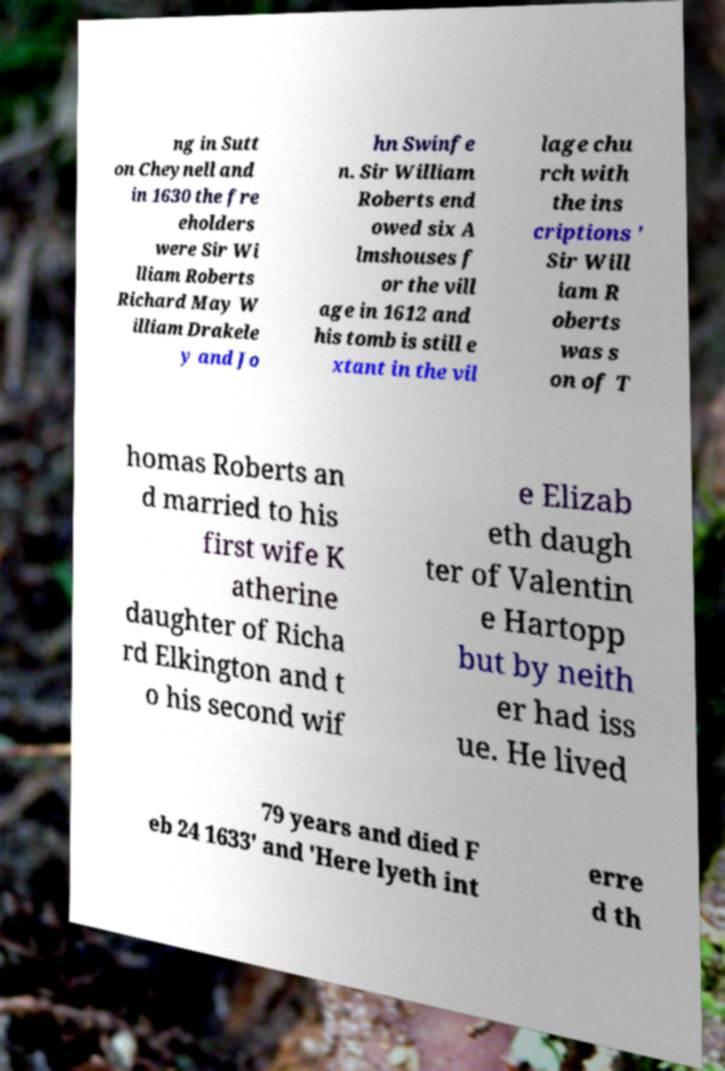I need the written content from this picture converted into text. Can you do that? ng in Sutt on Cheynell and in 1630 the fre eholders were Sir Wi lliam Roberts Richard May W illiam Drakele y and Jo hn Swinfe n. Sir William Roberts end owed six A lmshouses f or the vill age in 1612 and his tomb is still e xtant in the vil lage chu rch with the ins criptions ' Sir Will iam R oberts was s on of T homas Roberts an d married to his first wife K atherine daughter of Richa rd Elkington and t o his second wif e Elizab eth daugh ter of Valentin e Hartopp but by neith er had iss ue. He lived 79 years and died F eb 24 1633' and 'Here lyeth int erre d th 